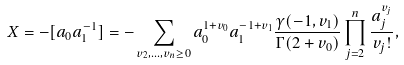<formula> <loc_0><loc_0><loc_500><loc_500>X = - [ a _ { 0 } a _ { 1 } ^ { - 1 } ] = - \sum _ { v _ { 2 } , \dots , v _ { n } \geq 0 } { a _ { 0 } ^ { 1 + v _ { 0 } } a _ { 1 } ^ { - 1 + v _ { 1 } } \frac { \gamma ( - 1 , v _ { 1 } ) } { \Gamma ( 2 + v _ { 0 } ) } \prod _ { j = 2 } ^ { n } { \frac { a _ { j } ^ { v _ { j } } } { v _ { j } ! } } } ,</formula> 